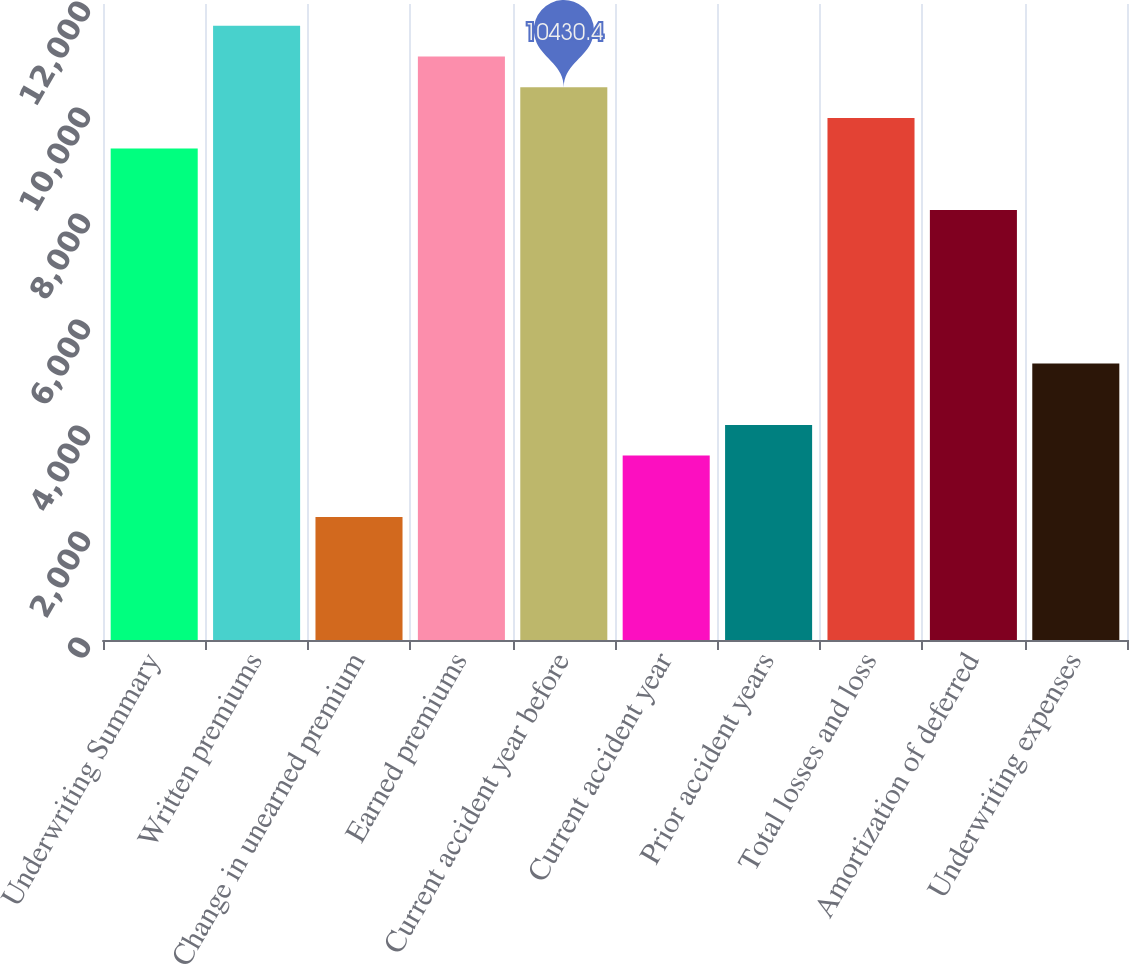Convert chart. <chart><loc_0><loc_0><loc_500><loc_500><bar_chart><fcel>Underwriting Summary<fcel>Written premiums<fcel>Change in unearned premium<fcel>Earned premiums<fcel>Current accident year before<fcel>Current accident year<fcel>Prior accident years<fcel>Total losses and loss<fcel>Amortization of deferred<fcel>Underwriting expenses<nl><fcel>9271.8<fcel>11589<fcel>2320.2<fcel>11009.7<fcel>10430.4<fcel>3478.8<fcel>4058.1<fcel>9851.1<fcel>8113.2<fcel>5216.7<nl></chart> 